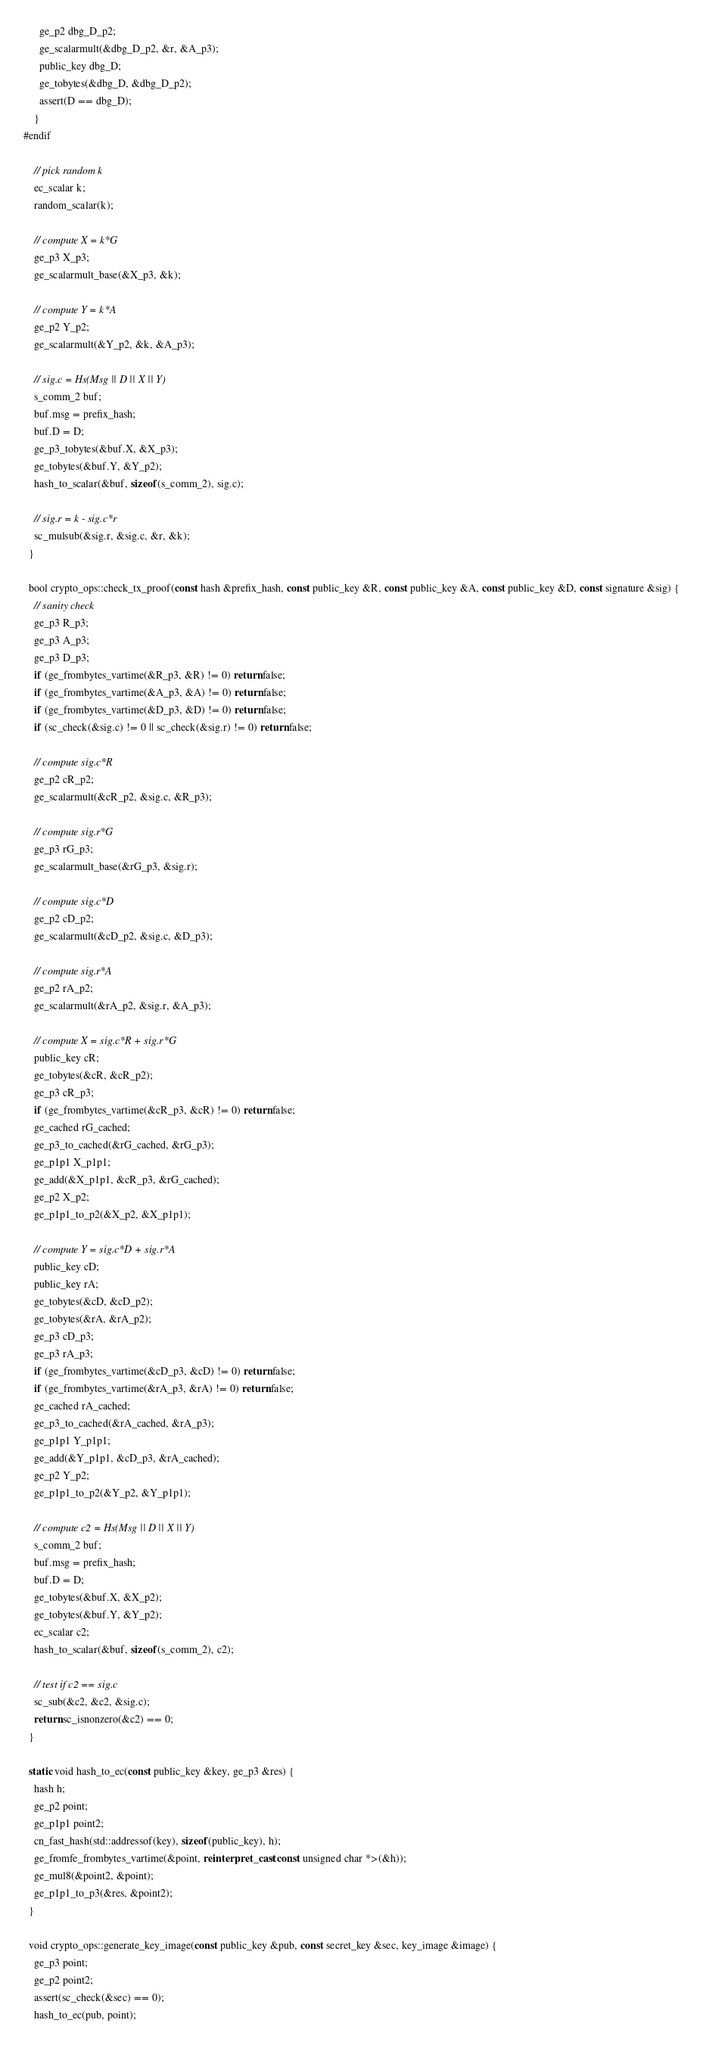Convert code to text. <code><loc_0><loc_0><loc_500><loc_500><_C++_>      ge_p2 dbg_D_p2;
      ge_scalarmult(&dbg_D_p2, &r, &A_p3);
      public_key dbg_D;
      ge_tobytes(&dbg_D, &dbg_D_p2);
      assert(D == dbg_D);
    }
#endif

    // pick random k
    ec_scalar k;
    random_scalar(k);
    
    // compute X = k*G
    ge_p3 X_p3;
    ge_scalarmult_base(&X_p3, &k);
    
    // compute Y = k*A
    ge_p2 Y_p2;
    ge_scalarmult(&Y_p2, &k, &A_p3);

    // sig.c = Hs(Msg || D || X || Y)
    s_comm_2 buf;
    buf.msg = prefix_hash;
    buf.D = D;
    ge_p3_tobytes(&buf.X, &X_p3);
    ge_tobytes(&buf.Y, &Y_p2);
    hash_to_scalar(&buf, sizeof(s_comm_2), sig.c);

    // sig.r = k - sig.c*r
    sc_mulsub(&sig.r, &sig.c, &r, &k);
  }

  bool crypto_ops::check_tx_proof(const hash &prefix_hash, const public_key &R, const public_key &A, const public_key &D, const signature &sig) {
    // sanity check
    ge_p3 R_p3;
    ge_p3 A_p3;
    ge_p3 D_p3;
    if (ge_frombytes_vartime(&R_p3, &R) != 0) return false;
    if (ge_frombytes_vartime(&A_p3, &A) != 0) return false;
    if (ge_frombytes_vartime(&D_p3, &D) != 0) return false;
    if (sc_check(&sig.c) != 0 || sc_check(&sig.r) != 0) return false;

    // compute sig.c*R
    ge_p2 cR_p2;
    ge_scalarmult(&cR_p2, &sig.c, &R_p3);

    // compute sig.r*G
    ge_p3 rG_p3;
    ge_scalarmult_base(&rG_p3, &sig.r);

    // compute sig.c*D
    ge_p2 cD_p2;
    ge_scalarmult(&cD_p2, &sig.c, &D_p3);

    // compute sig.r*A
    ge_p2 rA_p2;
    ge_scalarmult(&rA_p2, &sig.r, &A_p3);

    // compute X = sig.c*R + sig.r*G
    public_key cR;
    ge_tobytes(&cR, &cR_p2);
    ge_p3 cR_p3;
    if (ge_frombytes_vartime(&cR_p3, &cR) != 0) return false;
    ge_cached rG_cached;
    ge_p3_to_cached(&rG_cached, &rG_p3);
    ge_p1p1 X_p1p1;
    ge_add(&X_p1p1, &cR_p3, &rG_cached);
    ge_p2 X_p2;
    ge_p1p1_to_p2(&X_p2, &X_p1p1);

    // compute Y = sig.c*D + sig.r*A
    public_key cD;
    public_key rA;
    ge_tobytes(&cD, &cD_p2);
    ge_tobytes(&rA, &rA_p2);
    ge_p3 cD_p3;
    ge_p3 rA_p3;
    if (ge_frombytes_vartime(&cD_p3, &cD) != 0) return false;
    if (ge_frombytes_vartime(&rA_p3, &rA) != 0) return false;
    ge_cached rA_cached;
    ge_p3_to_cached(&rA_cached, &rA_p3);
    ge_p1p1 Y_p1p1;
    ge_add(&Y_p1p1, &cD_p3, &rA_cached);
    ge_p2 Y_p2;
    ge_p1p1_to_p2(&Y_p2, &Y_p1p1);

    // compute c2 = Hs(Msg || D || X || Y)
    s_comm_2 buf;
    buf.msg = prefix_hash;
    buf.D = D;
    ge_tobytes(&buf.X, &X_p2);
    ge_tobytes(&buf.Y, &Y_p2);
    ec_scalar c2;
    hash_to_scalar(&buf, sizeof(s_comm_2), c2);

    // test if c2 == sig.c
    sc_sub(&c2, &c2, &sig.c);
    return sc_isnonzero(&c2) == 0;
  }

  static void hash_to_ec(const public_key &key, ge_p3 &res) {
    hash h;
    ge_p2 point;
    ge_p1p1 point2;
    cn_fast_hash(std::addressof(key), sizeof(public_key), h);
    ge_fromfe_frombytes_vartime(&point, reinterpret_cast<const unsigned char *>(&h));
    ge_mul8(&point2, &point);
    ge_p1p1_to_p3(&res, &point2);
  }

  void crypto_ops::generate_key_image(const public_key &pub, const secret_key &sec, key_image &image) {
    ge_p3 point;
    ge_p2 point2;
    assert(sc_check(&sec) == 0);
    hash_to_ec(pub, point);</code> 